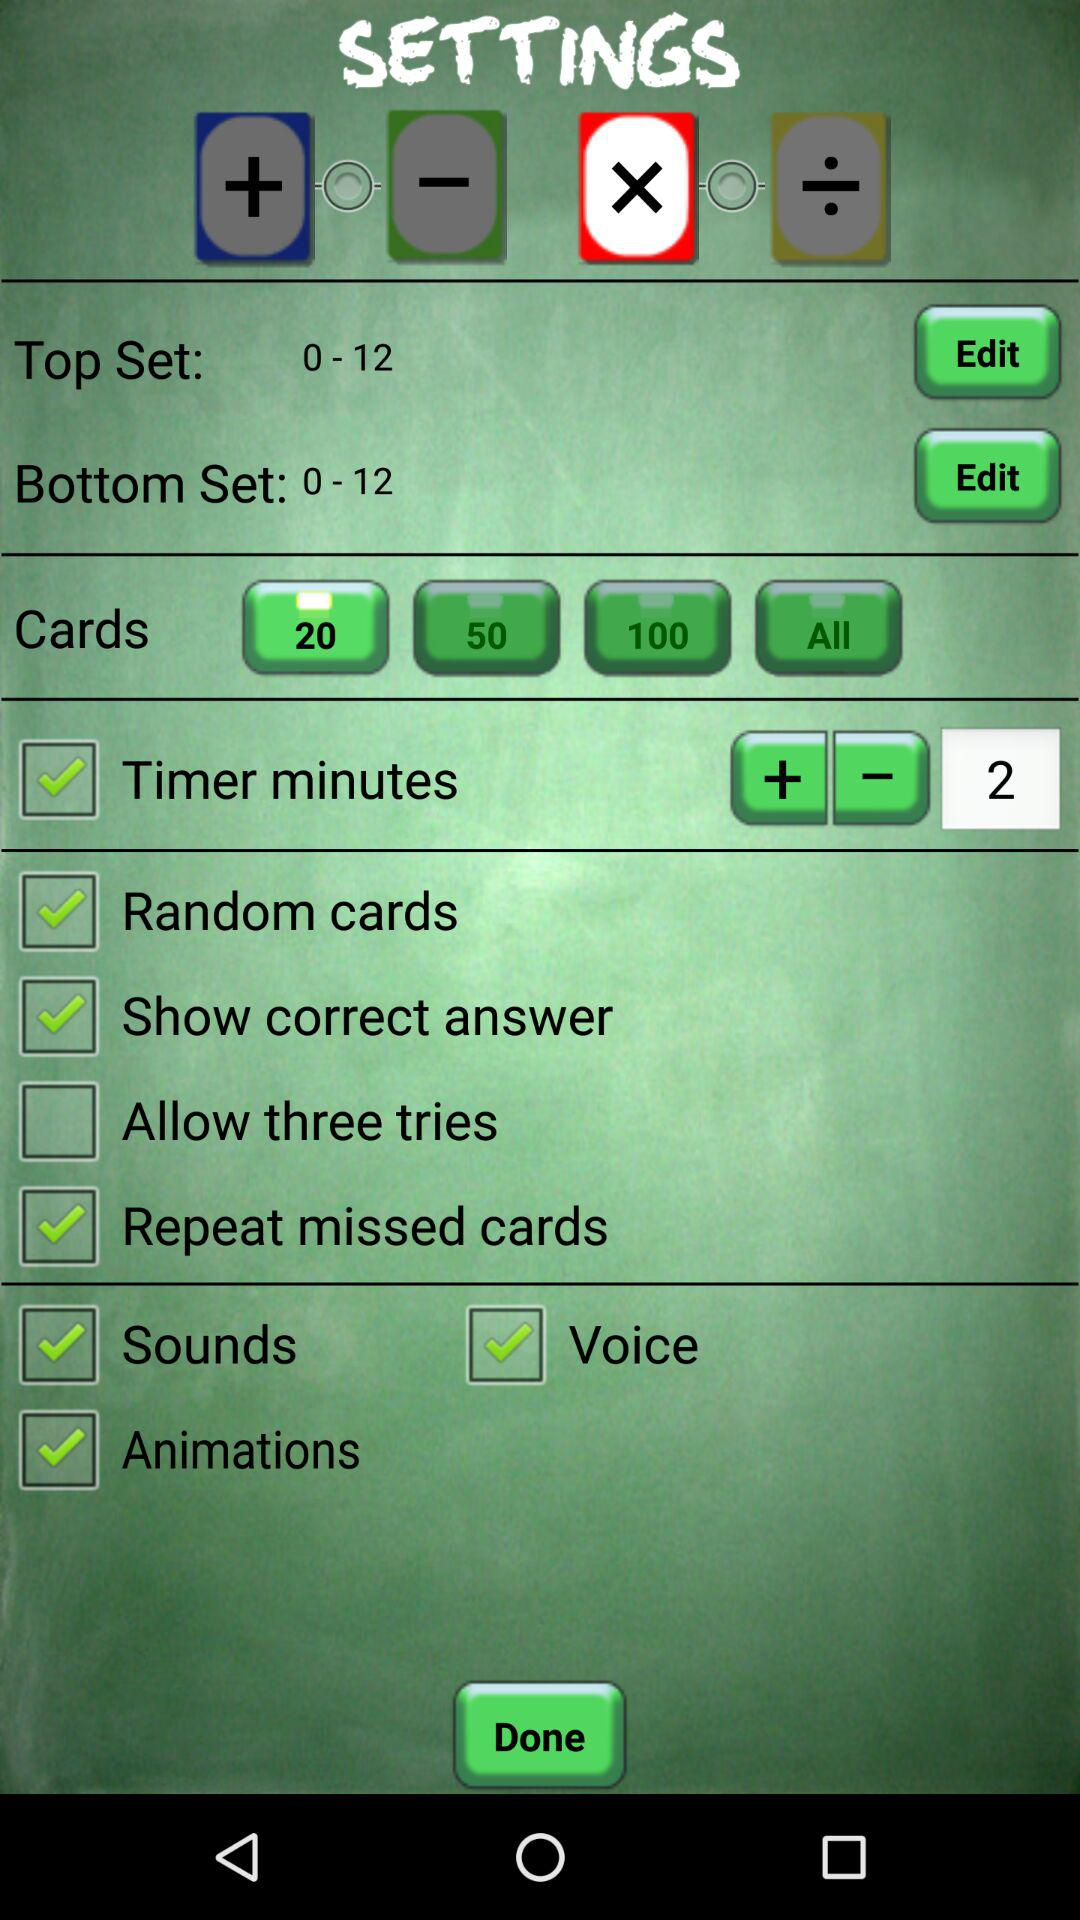What is the current status of "Sounds"? The status is on. 